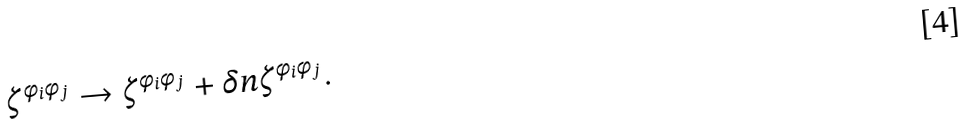Convert formula to latex. <formula><loc_0><loc_0><loc_500><loc_500>\zeta ^ { \phi _ { i } \phi _ { j } } \to \zeta ^ { \phi _ { i } \phi _ { j } } + \delta n \zeta ^ { \phi _ { i } \phi _ { j } } .</formula> 